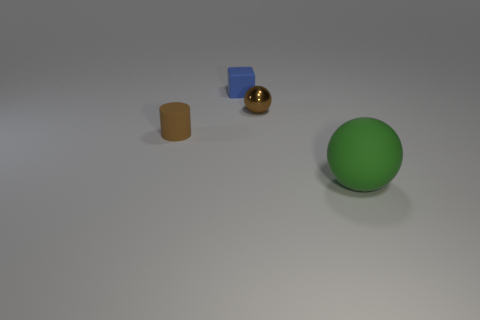How many other big green objects have the same material as the large thing? In the image, there are no other big green objects present with the same material as the large green ball which appears to have a matte finish. 